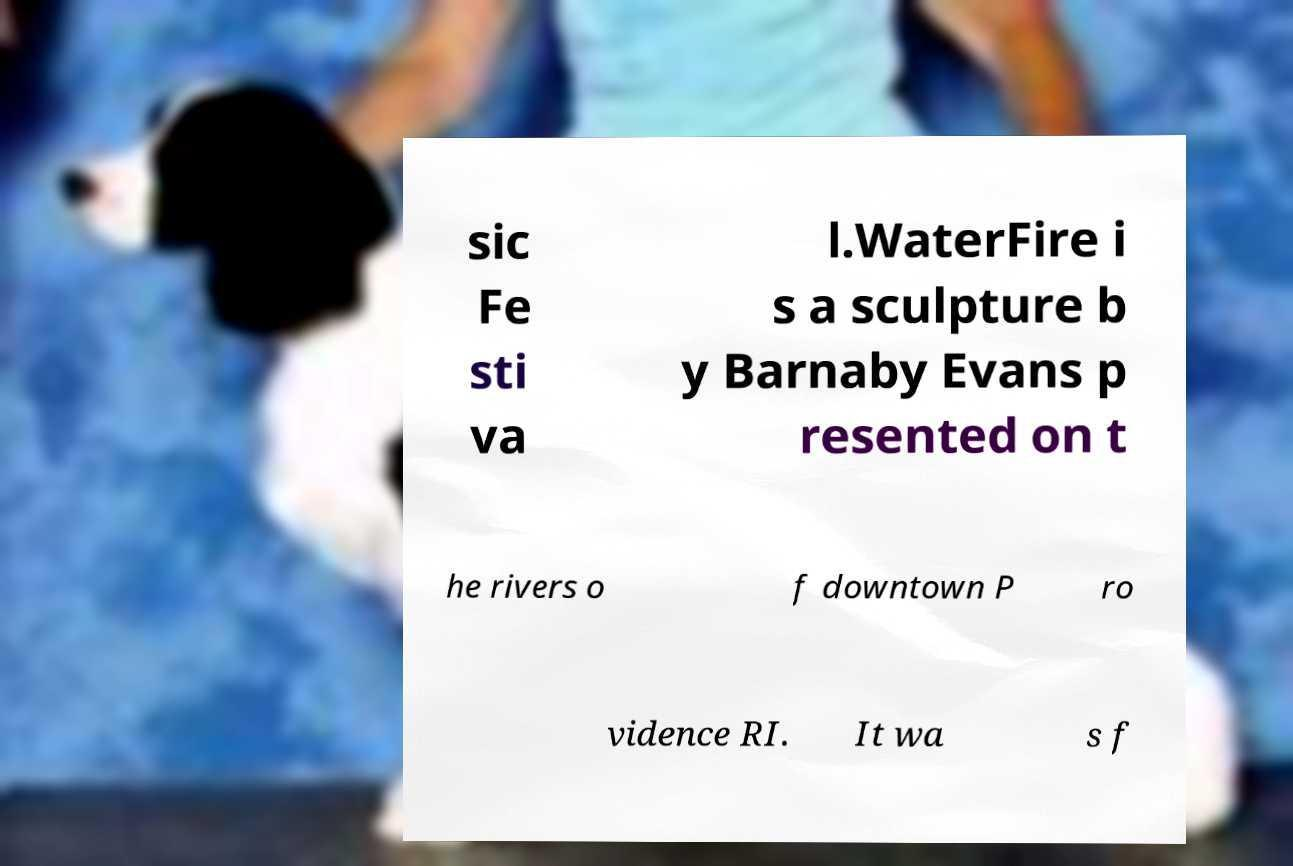Could you extract and type out the text from this image? sic Fe sti va l.WaterFire i s a sculpture b y Barnaby Evans p resented on t he rivers o f downtown P ro vidence RI. It wa s f 